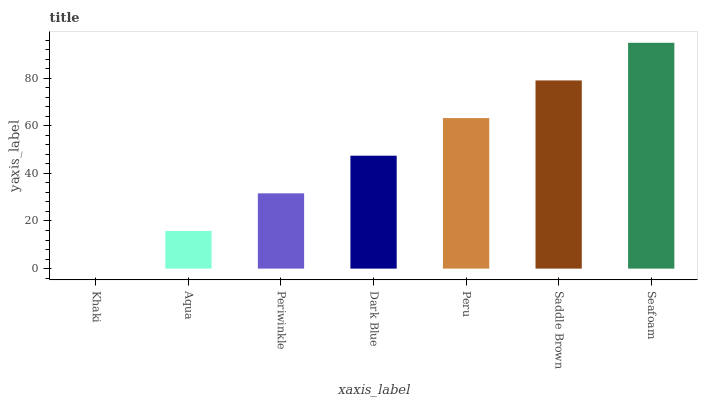Is Aqua the minimum?
Answer yes or no. No. Is Aqua the maximum?
Answer yes or no. No. Is Aqua greater than Khaki?
Answer yes or no. Yes. Is Khaki less than Aqua?
Answer yes or no. Yes. Is Khaki greater than Aqua?
Answer yes or no. No. Is Aqua less than Khaki?
Answer yes or no. No. Is Dark Blue the high median?
Answer yes or no. Yes. Is Dark Blue the low median?
Answer yes or no. Yes. Is Aqua the high median?
Answer yes or no. No. Is Aqua the low median?
Answer yes or no. No. 